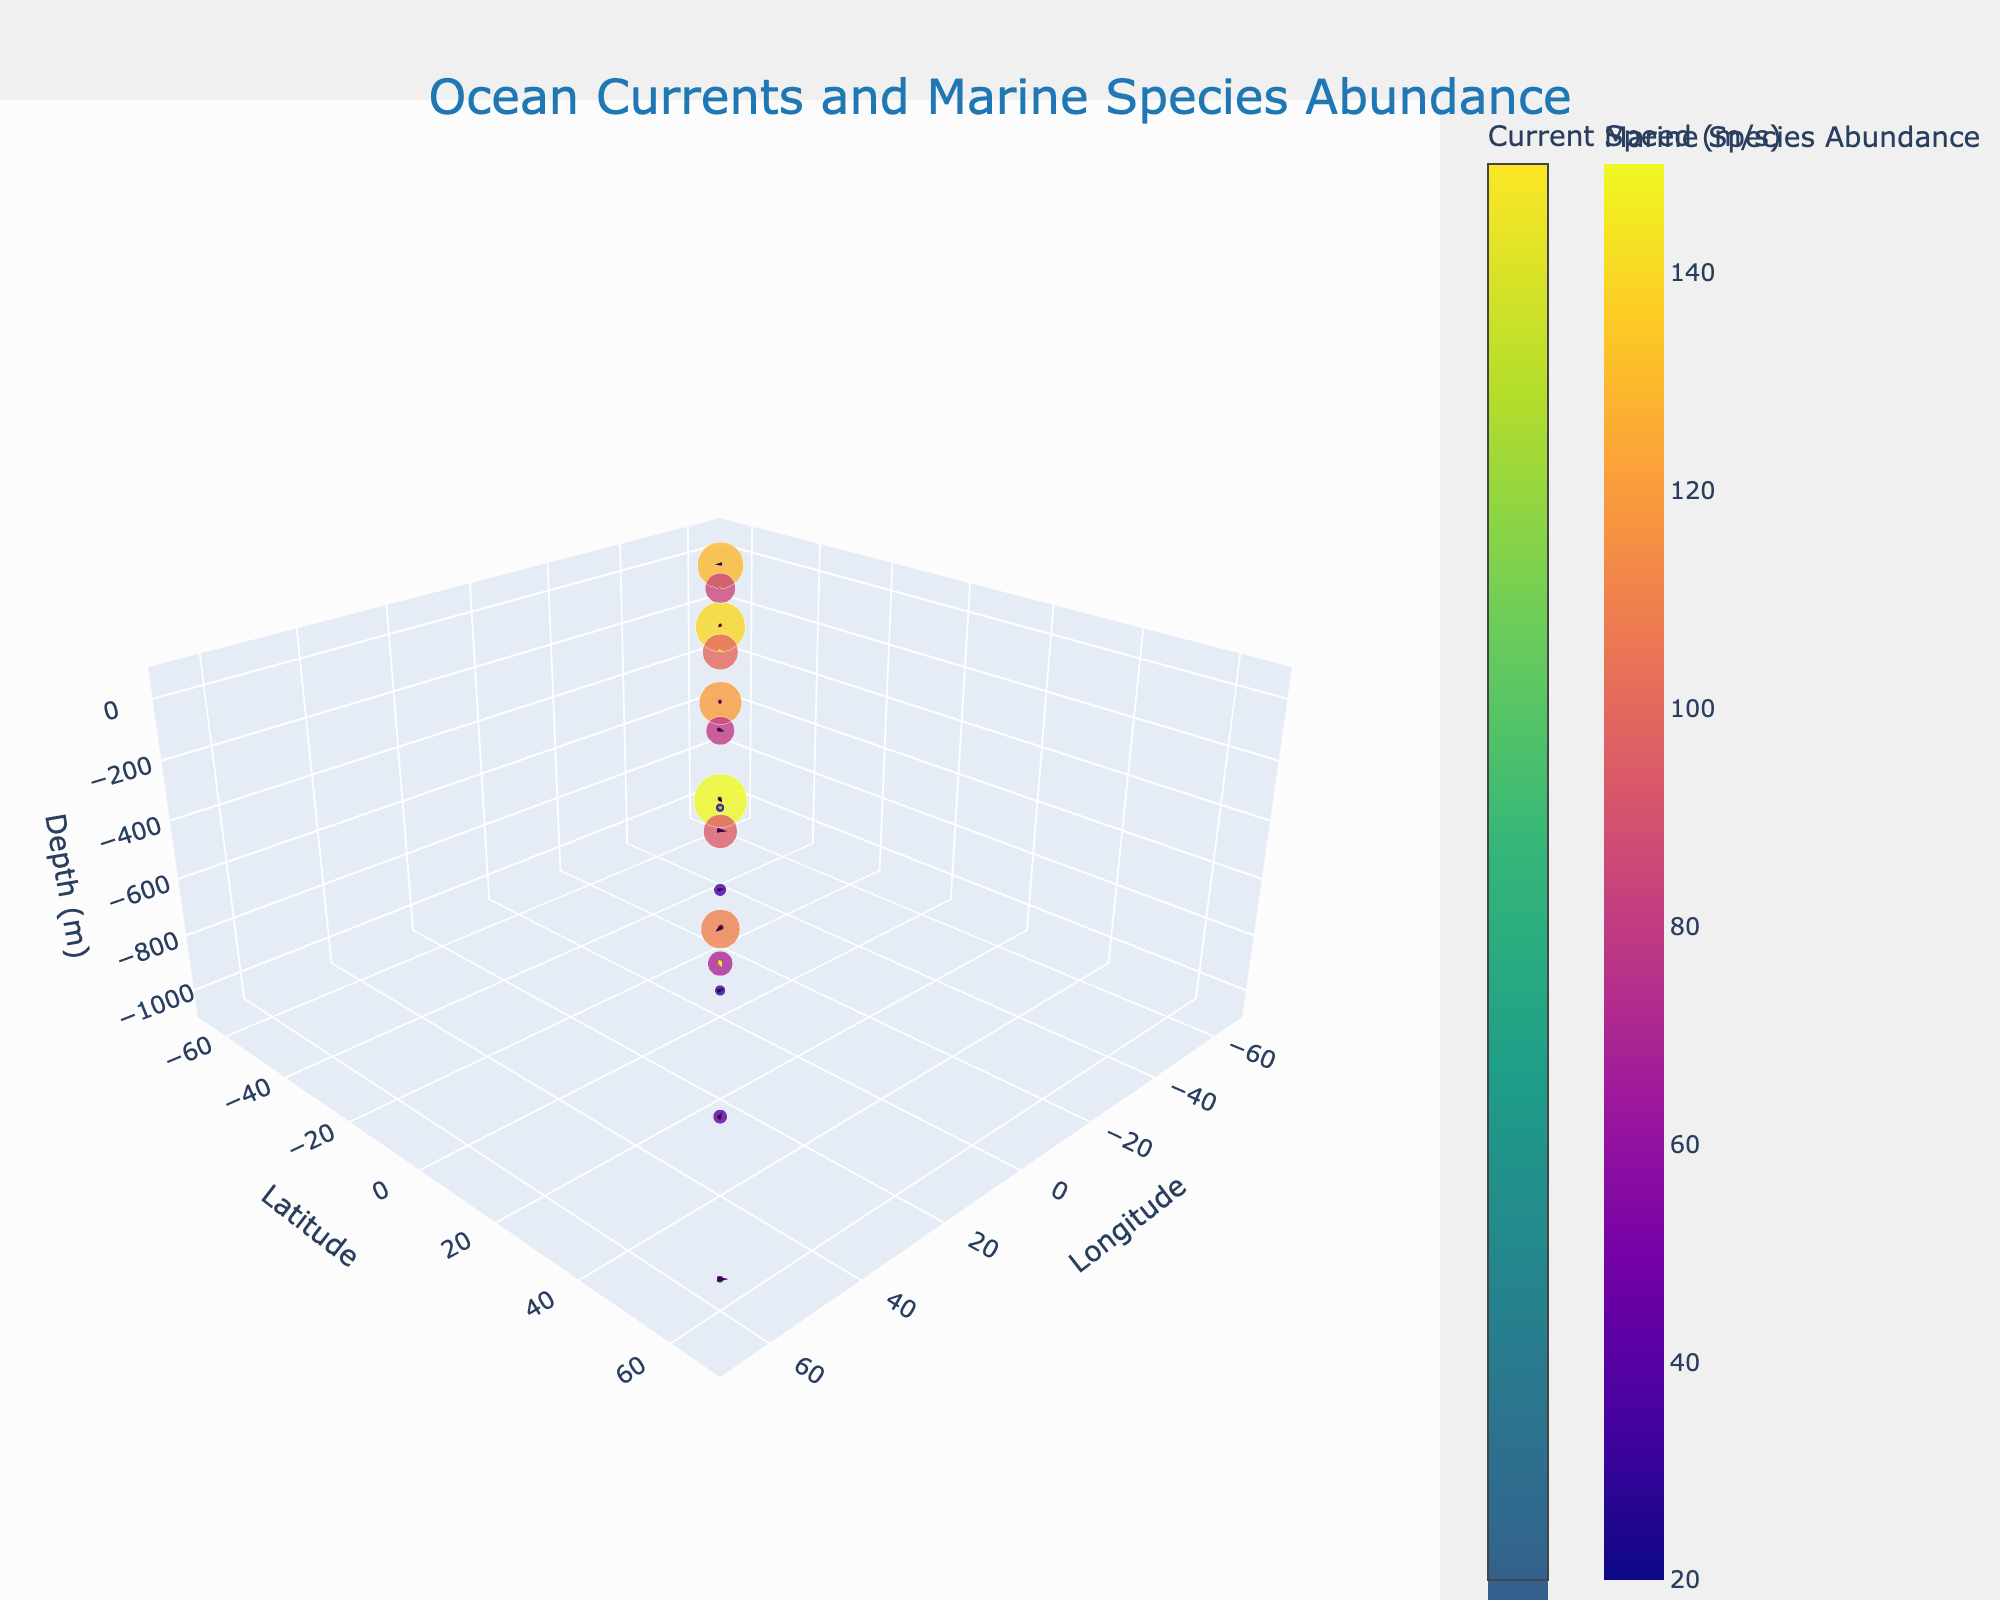What is the title of the plot? The title of the plot is displayed at the top.
Answer: Ocean Currents and Marine Species Abundance What is the range of the z-axis (depth)? The z-axis in the plot ranges from -1100 meters to 100 meters, as indicated by the axis labels.
Answer: -1100 to 100 meters How many uniquely different depths are represented in the plot? You can see points at various depths along the z-axis. The unique depths are 10 meters, 100 meters, and 1000 meters.
Answer: 3 Which location has the highest marine species abundance at 10 meters depth? Looking at the scatter plot with markers, we select those at depth 10 meters (-10 on the z-axis) and then identify the one with the largest marker size corresponding to marine species abundance.
Answer: Location: (30, 30) At which latitude is the marine species abundance the highest at 1000 meters depth? By locating the points at 1000 meters depth (z-axis at -1000), we then compare the sizes of the markers to determine the largest.
Answer: Latitude: 30 Which current direction appears most frequently at 10 meters depth? Examine the orientations of the cones at 10 meters depth (-10 on the z-axis). The directions correspond to the directions of the vectors.
Answer: Direction: any of (15, 30, 45, 60, 330) Are there more data points in the northern or southern hemisphere? Count the data points above and below the equator (latitude = 0).
Answer: Equal (4 in North, 4 in South) Compare the average current speed at 10 meters depth to 100 meters depth. Which is higher? Calculate the average current speed for both depths by adding their speeds and dividing by the number of observations.
Answer: 10 meters depth What is the average marine species abundance at -30 latitude? Sum the marine species abundance values for each point at latitude -30 and divide by the number of such points.
Answer: Average abundance: (140 + 100 + 35) / 3 